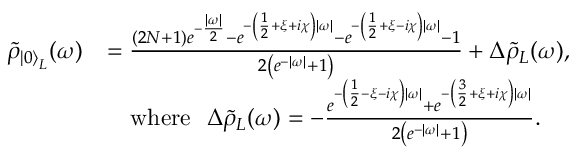<formula> <loc_0><loc_0><loc_500><loc_500>\begin{array} { r l } { \tilde { \rho } _ { { \left | 0 \right \rangle } _ { L } } ( \omega ) } & { = \frac { ( 2 N + 1 ) e ^ { - \frac { | \omega | } { 2 } } - e ^ { - \left ( \frac { 1 } { 2 } + \xi + i \chi \right ) | \omega | } - e ^ { - \left ( \frac { 1 } { 2 } + \xi - i \chi \right ) | \omega | } - 1 } { 2 \left ( e ^ { - | \omega | } + 1 \right ) } + \Delta \tilde { \rho } _ { L } ( \omega ) , } \\ & { \quad w h e r e \Delta \tilde { \rho } _ { L } ( \omega ) = - \frac { e ^ { - \left ( \frac { 1 } { 2 } - \xi - i \chi \right ) | \omega | } + e ^ { - \left ( \frac { 3 } { 2 } + \xi + i \chi \right ) | \omega | } } { 2 \left ( e ^ { - | \omega | } + 1 \right ) } . } \end{array}</formula> 